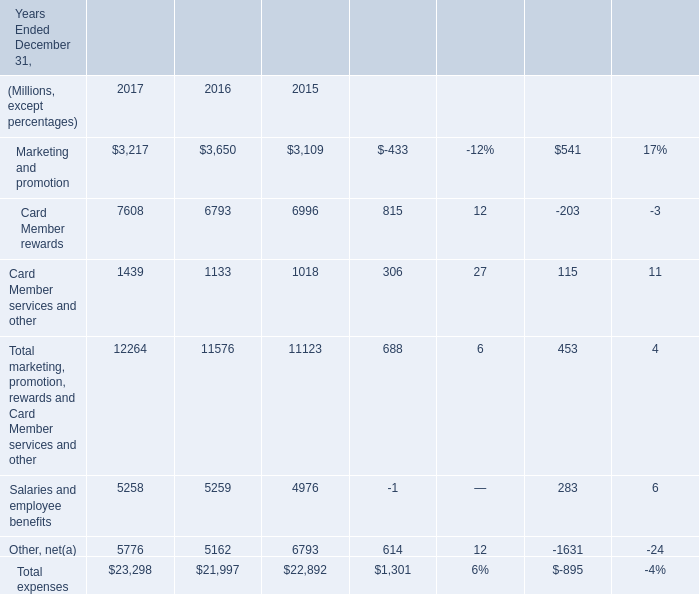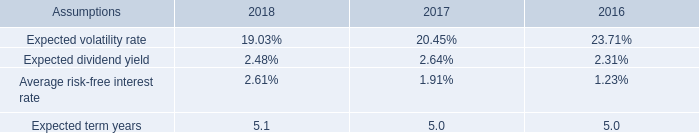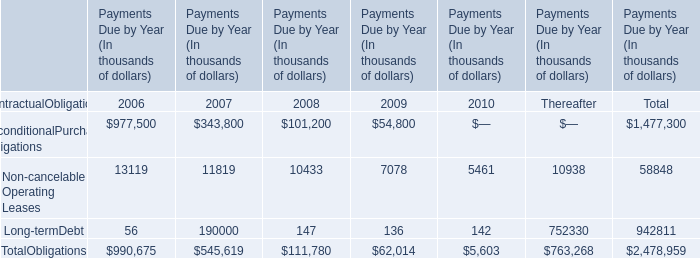what was the sum of the approximate compensation expense recognized in millions 
Computations: ((3 + 2) + 2)
Answer: 7.0. 